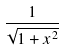<formula> <loc_0><loc_0><loc_500><loc_500>\frac { 1 } { \sqrt { 1 + x ^ { 2 } } }</formula> 